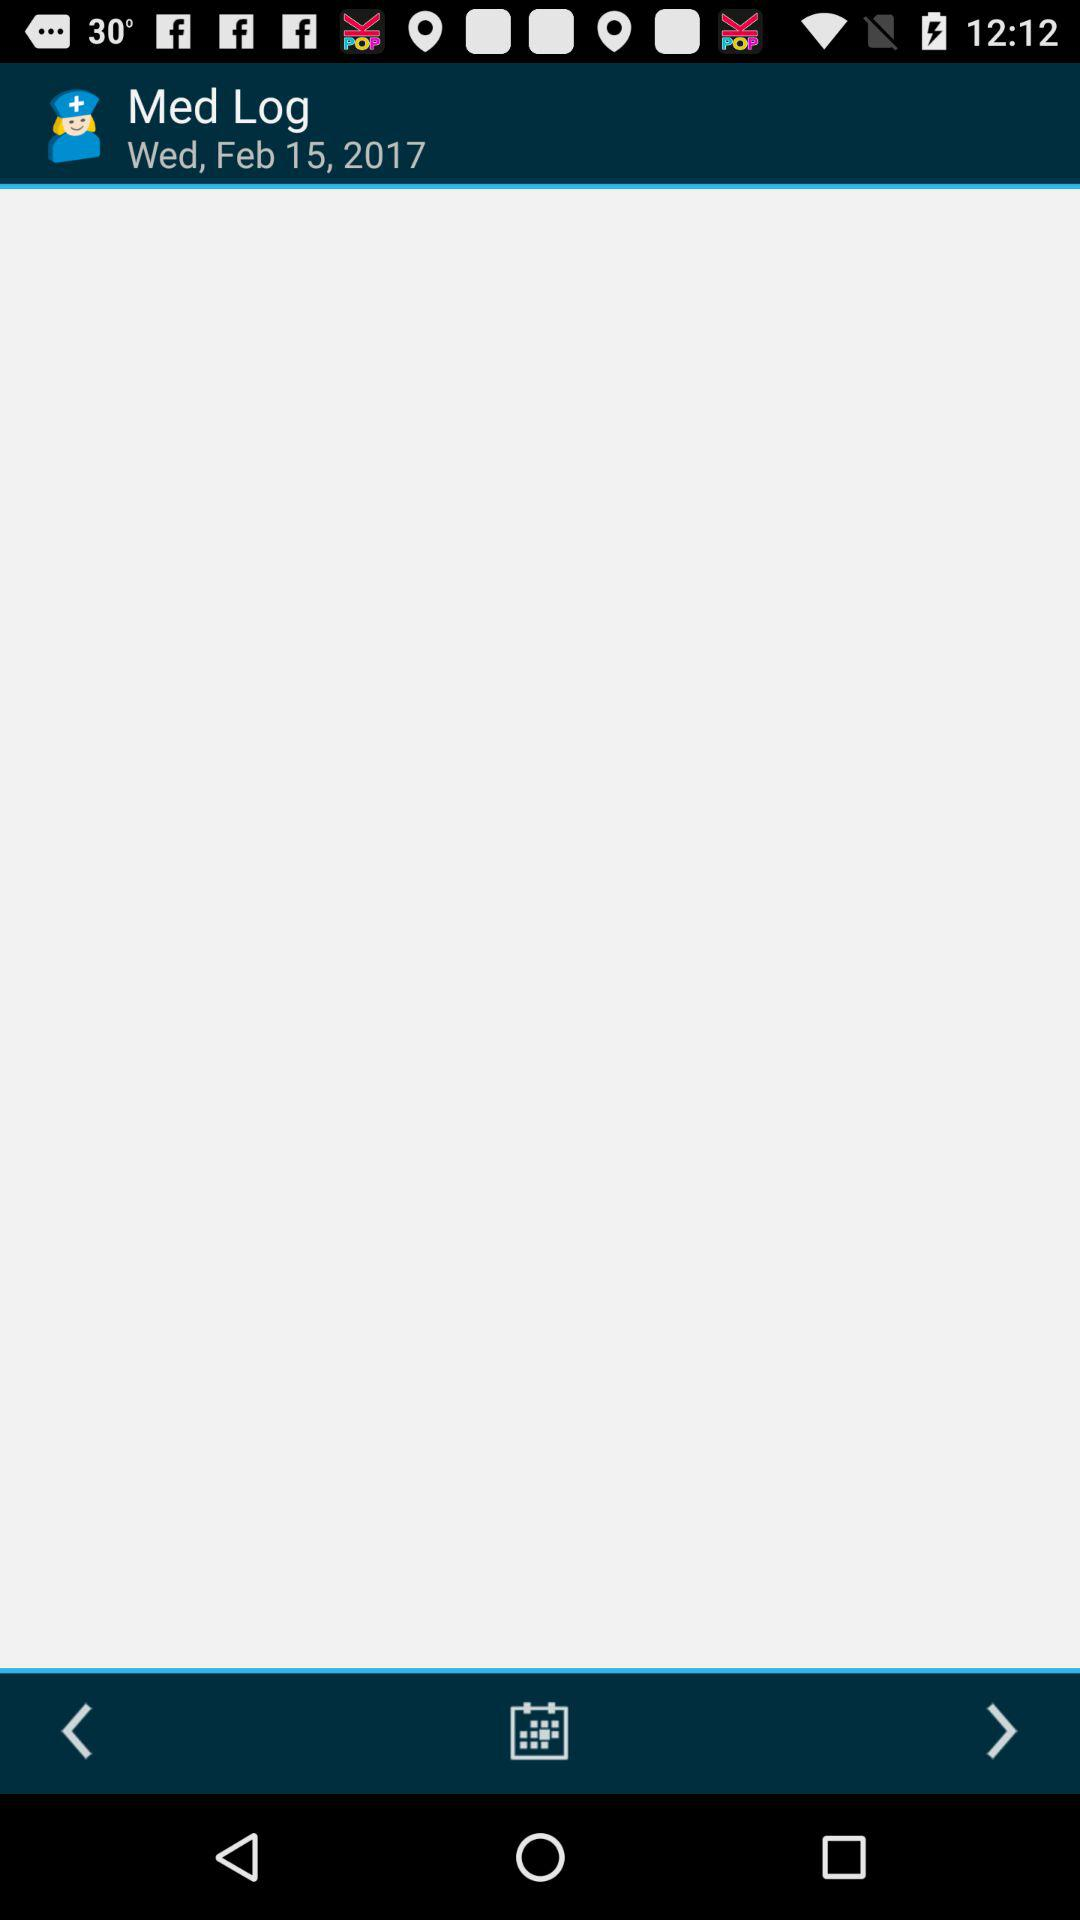What is the date and day? The date is February 15, 2017 and the day is Wednesday. 